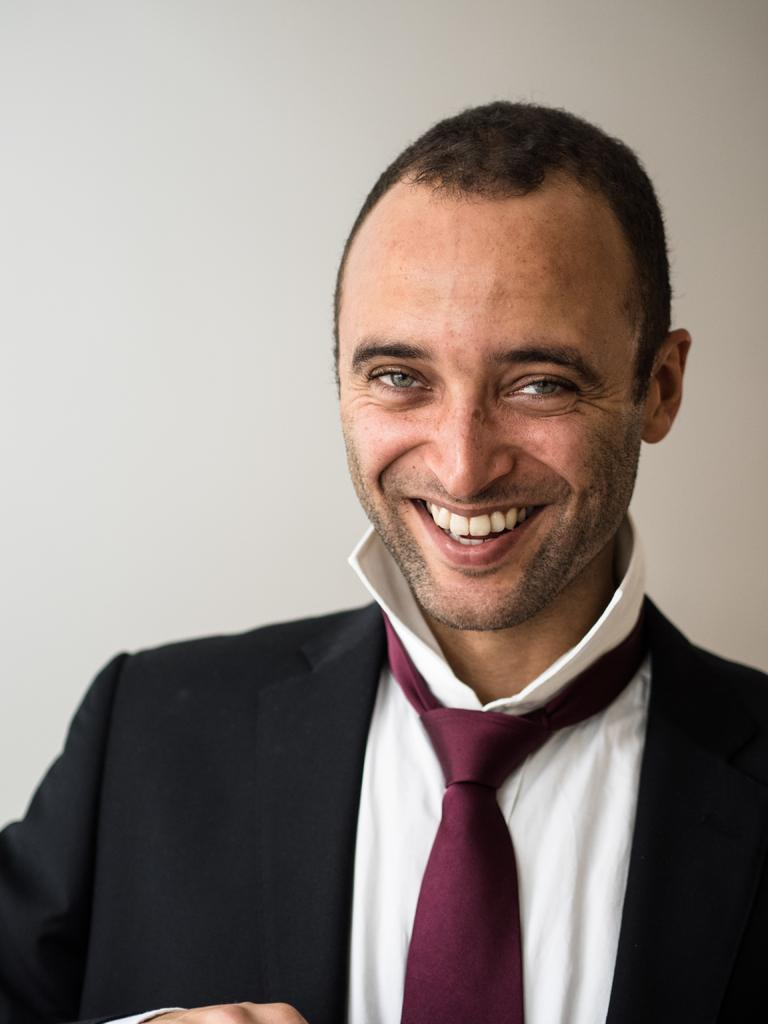What is the main subject of the image? The main subject of the image is a man. What is the man wearing? The man is wearing a black suit, a white shirt, and a maroon tie. What is the man's facial expression? The man is smiling. What can be seen behind the man? There is a wall behind the man. How many cherries are hanging from the man's tie in the image? There are no cherries present in the image, and therefore none are hanging from the man's tie. 